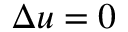<formula> <loc_0><loc_0><loc_500><loc_500>\Delta u = 0</formula> 